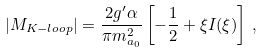<formula> <loc_0><loc_0><loc_500><loc_500>| M _ { K - l o o p } | = \frac { 2 g ^ { \prime } \alpha } { \pi m ^ { 2 } _ { a _ { 0 } } } \left [ - \frac { 1 } { 2 } + \xi I ( \xi ) \right ] \, ,</formula> 